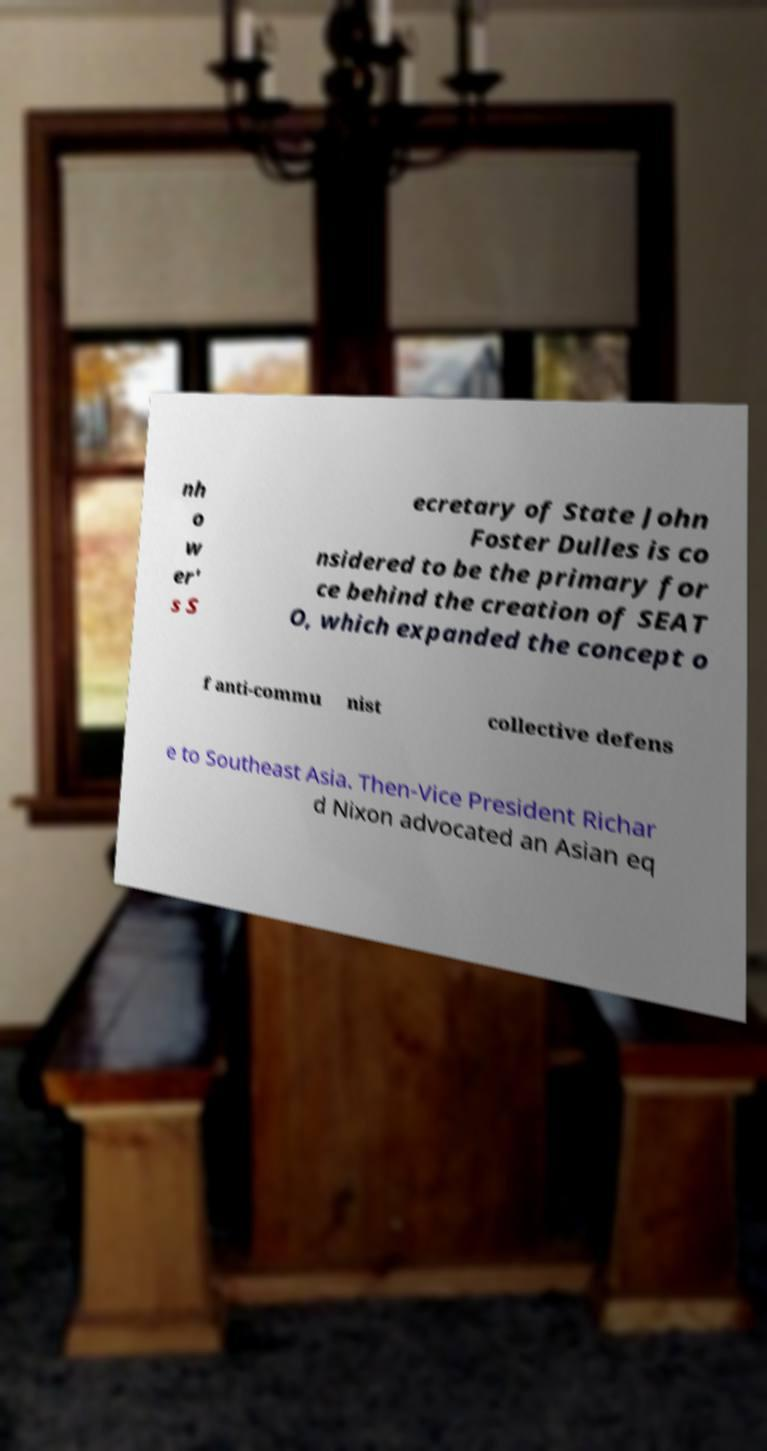Can you accurately transcribe the text from the provided image for me? nh o w er' s S ecretary of State John Foster Dulles is co nsidered to be the primary for ce behind the creation of SEAT O, which expanded the concept o f anti-commu nist collective defens e to Southeast Asia. Then-Vice President Richar d Nixon advocated an Asian eq 